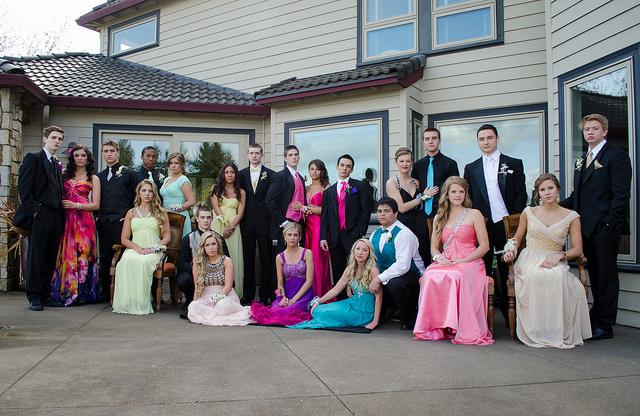Why is everyone posed so ornately?

Choices:
A) school pictures
B) bus stop
C) dinner waiting
D) wedding photo wedding photo 